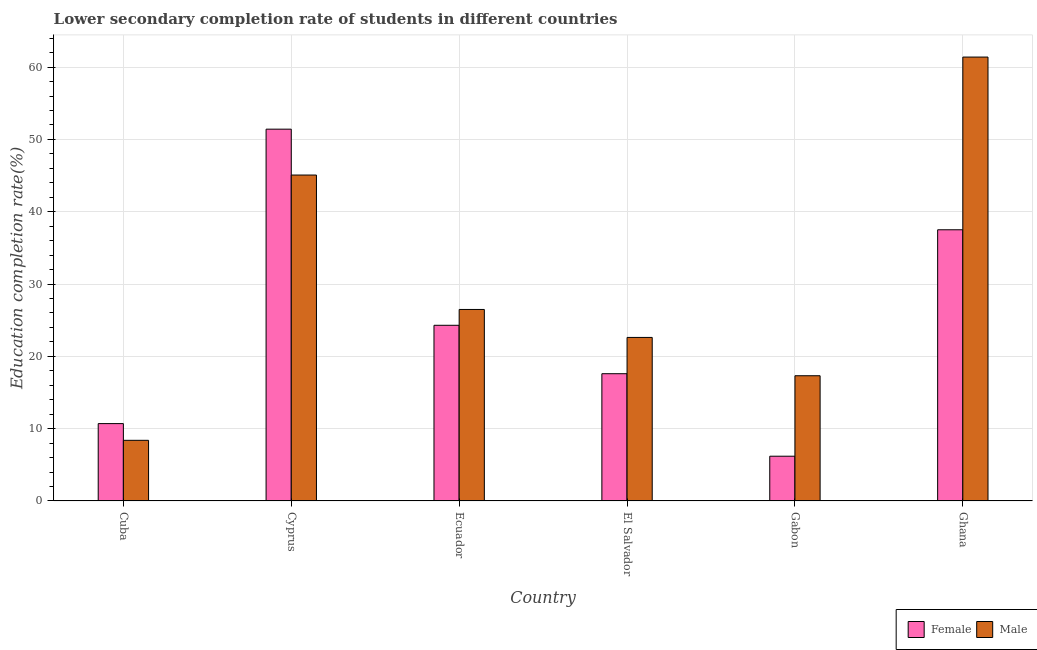How many different coloured bars are there?
Offer a very short reply. 2. Are the number of bars per tick equal to the number of legend labels?
Ensure brevity in your answer.  Yes. How many bars are there on the 5th tick from the left?
Give a very brief answer. 2. How many bars are there on the 3rd tick from the right?
Provide a short and direct response. 2. What is the label of the 4th group of bars from the left?
Provide a short and direct response. El Salvador. What is the education completion rate of male students in Gabon?
Ensure brevity in your answer.  17.32. Across all countries, what is the maximum education completion rate of male students?
Ensure brevity in your answer.  61.39. Across all countries, what is the minimum education completion rate of male students?
Your response must be concise. 8.39. In which country was the education completion rate of male students maximum?
Your answer should be very brief. Ghana. In which country was the education completion rate of male students minimum?
Provide a short and direct response. Cuba. What is the total education completion rate of male students in the graph?
Give a very brief answer. 181.28. What is the difference between the education completion rate of female students in El Salvador and that in Gabon?
Keep it short and to the point. 11.41. What is the difference between the education completion rate of female students in Ecuador and the education completion rate of male students in Cyprus?
Ensure brevity in your answer.  -20.78. What is the average education completion rate of female students per country?
Your answer should be compact. 24.62. What is the difference between the education completion rate of female students and education completion rate of male students in Ecuador?
Your response must be concise. -2.19. What is the ratio of the education completion rate of female students in Cyprus to that in Gabon?
Your response must be concise. 8.3. Is the education completion rate of female students in Cyprus less than that in Ghana?
Make the answer very short. No. What is the difference between the highest and the second highest education completion rate of male students?
Your response must be concise. 16.31. What is the difference between the highest and the lowest education completion rate of female students?
Your answer should be compact. 45.23. Is the sum of the education completion rate of male students in Cyprus and Ecuador greater than the maximum education completion rate of female students across all countries?
Your answer should be very brief. Yes. What does the 2nd bar from the left in Gabon represents?
Your answer should be compact. Male. What does the 1st bar from the right in Ecuador represents?
Your response must be concise. Male. Are all the bars in the graph horizontal?
Your answer should be very brief. No. What is the difference between two consecutive major ticks on the Y-axis?
Provide a short and direct response. 10. Where does the legend appear in the graph?
Make the answer very short. Bottom right. How are the legend labels stacked?
Your answer should be compact. Horizontal. What is the title of the graph?
Make the answer very short. Lower secondary completion rate of students in different countries. What is the label or title of the X-axis?
Offer a very short reply. Country. What is the label or title of the Y-axis?
Make the answer very short. Education completion rate(%). What is the Education completion rate(%) in Female in Cuba?
Your answer should be compact. 10.7. What is the Education completion rate(%) of Male in Cuba?
Keep it short and to the point. 8.39. What is the Education completion rate(%) in Female in Cyprus?
Offer a terse response. 51.42. What is the Education completion rate(%) of Male in Cyprus?
Give a very brief answer. 45.08. What is the Education completion rate(%) of Female in Ecuador?
Give a very brief answer. 24.3. What is the Education completion rate(%) of Male in Ecuador?
Provide a succinct answer. 26.49. What is the Education completion rate(%) of Female in El Salvador?
Your answer should be compact. 17.6. What is the Education completion rate(%) of Male in El Salvador?
Make the answer very short. 22.62. What is the Education completion rate(%) in Female in Gabon?
Your response must be concise. 6.19. What is the Education completion rate(%) of Male in Gabon?
Make the answer very short. 17.32. What is the Education completion rate(%) in Female in Ghana?
Offer a terse response. 37.51. What is the Education completion rate(%) of Male in Ghana?
Ensure brevity in your answer.  61.39. Across all countries, what is the maximum Education completion rate(%) of Female?
Ensure brevity in your answer.  51.42. Across all countries, what is the maximum Education completion rate(%) in Male?
Make the answer very short. 61.39. Across all countries, what is the minimum Education completion rate(%) in Female?
Offer a very short reply. 6.19. Across all countries, what is the minimum Education completion rate(%) of Male?
Your answer should be very brief. 8.39. What is the total Education completion rate(%) of Female in the graph?
Keep it short and to the point. 147.72. What is the total Education completion rate(%) of Male in the graph?
Keep it short and to the point. 181.28. What is the difference between the Education completion rate(%) in Female in Cuba and that in Cyprus?
Your answer should be compact. -40.72. What is the difference between the Education completion rate(%) in Male in Cuba and that in Cyprus?
Keep it short and to the point. -36.69. What is the difference between the Education completion rate(%) of Female in Cuba and that in Ecuador?
Give a very brief answer. -13.6. What is the difference between the Education completion rate(%) in Male in Cuba and that in Ecuador?
Give a very brief answer. -18.1. What is the difference between the Education completion rate(%) in Female in Cuba and that in El Salvador?
Your answer should be compact. -6.9. What is the difference between the Education completion rate(%) in Male in Cuba and that in El Salvador?
Offer a very short reply. -14.23. What is the difference between the Education completion rate(%) of Female in Cuba and that in Gabon?
Ensure brevity in your answer.  4.51. What is the difference between the Education completion rate(%) of Male in Cuba and that in Gabon?
Your response must be concise. -8.93. What is the difference between the Education completion rate(%) in Female in Cuba and that in Ghana?
Make the answer very short. -26.81. What is the difference between the Education completion rate(%) in Male in Cuba and that in Ghana?
Ensure brevity in your answer.  -53. What is the difference between the Education completion rate(%) of Female in Cyprus and that in Ecuador?
Your response must be concise. 27.12. What is the difference between the Education completion rate(%) of Male in Cyprus and that in Ecuador?
Ensure brevity in your answer.  18.59. What is the difference between the Education completion rate(%) of Female in Cyprus and that in El Salvador?
Offer a very short reply. 33.82. What is the difference between the Education completion rate(%) of Male in Cyprus and that in El Salvador?
Your answer should be compact. 22.46. What is the difference between the Education completion rate(%) of Female in Cyprus and that in Gabon?
Offer a terse response. 45.23. What is the difference between the Education completion rate(%) in Male in Cyprus and that in Gabon?
Your response must be concise. 27.76. What is the difference between the Education completion rate(%) of Female in Cyprus and that in Ghana?
Make the answer very short. 13.91. What is the difference between the Education completion rate(%) of Male in Cyprus and that in Ghana?
Provide a succinct answer. -16.31. What is the difference between the Education completion rate(%) in Female in Ecuador and that in El Salvador?
Make the answer very short. 6.7. What is the difference between the Education completion rate(%) of Male in Ecuador and that in El Salvador?
Provide a short and direct response. 3.87. What is the difference between the Education completion rate(%) in Female in Ecuador and that in Gabon?
Give a very brief answer. 18.11. What is the difference between the Education completion rate(%) of Male in Ecuador and that in Gabon?
Give a very brief answer. 9.17. What is the difference between the Education completion rate(%) of Female in Ecuador and that in Ghana?
Make the answer very short. -13.21. What is the difference between the Education completion rate(%) of Male in Ecuador and that in Ghana?
Your answer should be very brief. -34.91. What is the difference between the Education completion rate(%) of Female in El Salvador and that in Gabon?
Ensure brevity in your answer.  11.41. What is the difference between the Education completion rate(%) in Male in El Salvador and that in Gabon?
Provide a succinct answer. 5.3. What is the difference between the Education completion rate(%) of Female in El Salvador and that in Ghana?
Your answer should be compact. -19.91. What is the difference between the Education completion rate(%) in Male in El Salvador and that in Ghana?
Your response must be concise. -38.77. What is the difference between the Education completion rate(%) in Female in Gabon and that in Ghana?
Make the answer very short. -31.32. What is the difference between the Education completion rate(%) of Male in Gabon and that in Ghana?
Keep it short and to the point. -44.07. What is the difference between the Education completion rate(%) of Female in Cuba and the Education completion rate(%) of Male in Cyprus?
Offer a terse response. -34.38. What is the difference between the Education completion rate(%) in Female in Cuba and the Education completion rate(%) in Male in Ecuador?
Offer a terse response. -15.79. What is the difference between the Education completion rate(%) in Female in Cuba and the Education completion rate(%) in Male in El Salvador?
Your response must be concise. -11.92. What is the difference between the Education completion rate(%) in Female in Cuba and the Education completion rate(%) in Male in Gabon?
Your answer should be very brief. -6.62. What is the difference between the Education completion rate(%) in Female in Cuba and the Education completion rate(%) in Male in Ghana?
Give a very brief answer. -50.69. What is the difference between the Education completion rate(%) in Female in Cyprus and the Education completion rate(%) in Male in Ecuador?
Provide a succinct answer. 24.93. What is the difference between the Education completion rate(%) in Female in Cyprus and the Education completion rate(%) in Male in El Salvador?
Keep it short and to the point. 28.8. What is the difference between the Education completion rate(%) in Female in Cyprus and the Education completion rate(%) in Male in Gabon?
Give a very brief answer. 34.1. What is the difference between the Education completion rate(%) of Female in Cyprus and the Education completion rate(%) of Male in Ghana?
Your response must be concise. -9.97. What is the difference between the Education completion rate(%) in Female in Ecuador and the Education completion rate(%) in Male in El Salvador?
Make the answer very short. 1.68. What is the difference between the Education completion rate(%) in Female in Ecuador and the Education completion rate(%) in Male in Gabon?
Your answer should be compact. 6.98. What is the difference between the Education completion rate(%) in Female in Ecuador and the Education completion rate(%) in Male in Ghana?
Give a very brief answer. -37.09. What is the difference between the Education completion rate(%) of Female in El Salvador and the Education completion rate(%) of Male in Gabon?
Your answer should be compact. 0.28. What is the difference between the Education completion rate(%) of Female in El Salvador and the Education completion rate(%) of Male in Ghana?
Offer a terse response. -43.79. What is the difference between the Education completion rate(%) of Female in Gabon and the Education completion rate(%) of Male in Ghana?
Ensure brevity in your answer.  -55.2. What is the average Education completion rate(%) of Female per country?
Provide a succinct answer. 24.62. What is the average Education completion rate(%) in Male per country?
Ensure brevity in your answer.  30.21. What is the difference between the Education completion rate(%) of Female and Education completion rate(%) of Male in Cuba?
Give a very brief answer. 2.31. What is the difference between the Education completion rate(%) in Female and Education completion rate(%) in Male in Cyprus?
Keep it short and to the point. 6.34. What is the difference between the Education completion rate(%) in Female and Education completion rate(%) in Male in Ecuador?
Make the answer very short. -2.19. What is the difference between the Education completion rate(%) in Female and Education completion rate(%) in Male in El Salvador?
Provide a succinct answer. -5.02. What is the difference between the Education completion rate(%) of Female and Education completion rate(%) of Male in Gabon?
Give a very brief answer. -11.13. What is the difference between the Education completion rate(%) of Female and Education completion rate(%) of Male in Ghana?
Your answer should be compact. -23.89. What is the ratio of the Education completion rate(%) in Female in Cuba to that in Cyprus?
Offer a terse response. 0.21. What is the ratio of the Education completion rate(%) of Male in Cuba to that in Cyprus?
Your response must be concise. 0.19. What is the ratio of the Education completion rate(%) in Female in Cuba to that in Ecuador?
Ensure brevity in your answer.  0.44. What is the ratio of the Education completion rate(%) in Male in Cuba to that in Ecuador?
Make the answer very short. 0.32. What is the ratio of the Education completion rate(%) in Female in Cuba to that in El Salvador?
Keep it short and to the point. 0.61. What is the ratio of the Education completion rate(%) of Male in Cuba to that in El Salvador?
Ensure brevity in your answer.  0.37. What is the ratio of the Education completion rate(%) of Female in Cuba to that in Gabon?
Your answer should be compact. 1.73. What is the ratio of the Education completion rate(%) of Male in Cuba to that in Gabon?
Your answer should be very brief. 0.48. What is the ratio of the Education completion rate(%) of Female in Cuba to that in Ghana?
Keep it short and to the point. 0.29. What is the ratio of the Education completion rate(%) in Male in Cuba to that in Ghana?
Give a very brief answer. 0.14. What is the ratio of the Education completion rate(%) in Female in Cyprus to that in Ecuador?
Offer a terse response. 2.12. What is the ratio of the Education completion rate(%) of Male in Cyprus to that in Ecuador?
Give a very brief answer. 1.7. What is the ratio of the Education completion rate(%) of Female in Cyprus to that in El Salvador?
Offer a very short reply. 2.92. What is the ratio of the Education completion rate(%) of Male in Cyprus to that in El Salvador?
Your answer should be compact. 1.99. What is the ratio of the Education completion rate(%) in Female in Cyprus to that in Gabon?
Provide a succinct answer. 8.3. What is the ratio of the Education completion rate(%) of Male in Cyprus to that in Gabon?
Offer a terse response. 2.6. What is the ratio of the Education completion rate(%) in Female in Cyprus to that in Ghana?
Give a very brief answer. 1.37. What is the ratio of the Education completion rate(%) of Male in Cyprus to that in Ghana?
Keep it short and to the point. 0.73. What is the ratio of the Education completion rate(%) in Female in Ecuador to that in El Salvador?
Provide a succinct answer. 1.38. What is the ratio of the Education completion rate(%) in Male in Ecuador to that in El Salvador?
Ensure brevity in your answer.  1.17. What is the ratio of the Education completion rate(%) in Female in Ecuador to that in Gabon?
Provide a succinct answer. 3.92. What is the ratio of the Education completion rate(%) in Male in Ecuador to that in Gabon?
Offer a very short reply. 1.53. What is the ratio of the Education completion rate(%) of Female in Ecuador to that in Ghana?
Keep it short and to the point. 0.65. What is the ratio of the Education completion rate(%) of Male in Ecuador to that in Ghana?
Make the answer very short. 0.43. What is the ratio of the Education completion rate(%) of Female in El Salvador to that in Gabon?
Your answer should be compact. 2.84. What is the ratio of the Education completion rate(%) of Male in El Salvador to that in Gabon?
Provide a succinct answer. 1.31. What is the ratio of the Education completion rate(%) of Female in El Salvador to that in Ghana?
Keep it short and to the point. 0.47. What is the ratio of the Education completion rate(%) in Male in El Salvador to that in Ghana?
Ensure brevity in your answer.  0.37. What is the ratio of the Education completion rate(%) of Female in Gabon to that in Ghana?
Keep it short and to the point. 0.17. What is the ratio of the Education completion rate(%) in Male in Gabon to that in Ghana?
Your answer should be very brief. 0.28. What is the difference between the highest and the second highest Education completion rate(%) in Female?
Give a very brief answer. 13.91. What is the difference between the highest and the second highest Education completion rate(%) of Male?
Ensure brevity in your answer.  16.31. What is the difference between the highest and the lowest Education completion rate(%) of Female?
Ensure brevity in your answer.  45.23. What is the difference between the highest and the lowest Education completion rate(%) of Male?
Give a very brief answer. 53. 